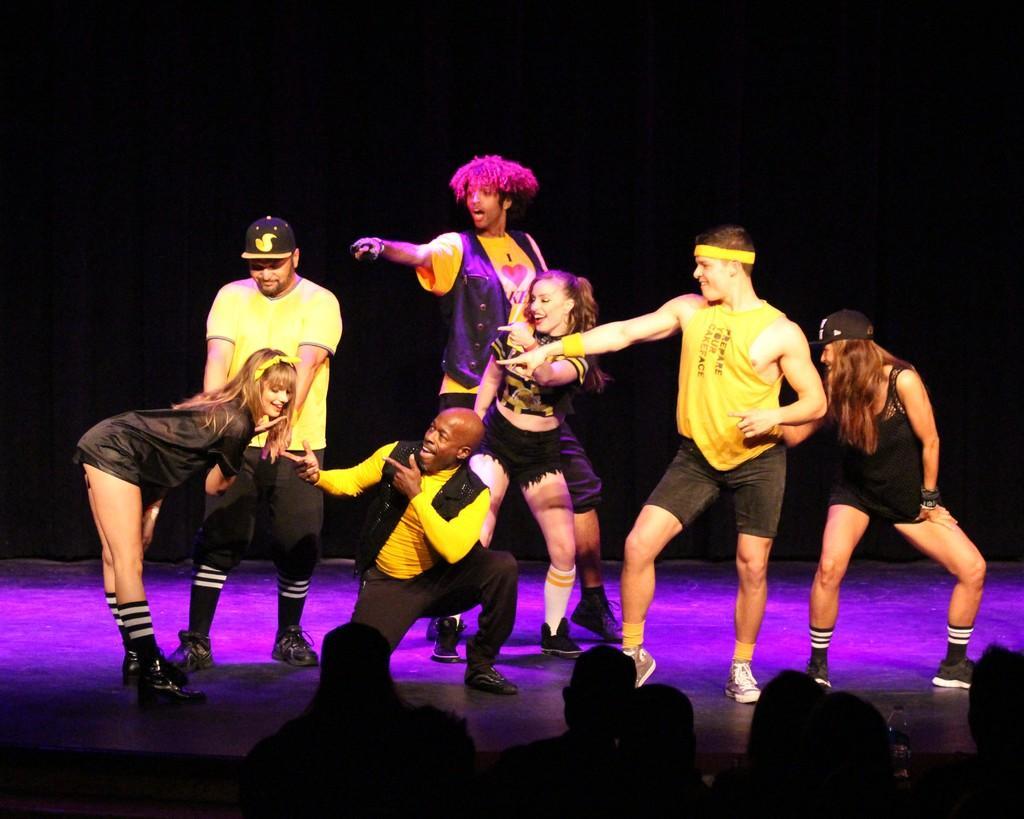Can you describe this image briefly? In this image ,people who are at the bottom are looking at the people who are on the stage. 